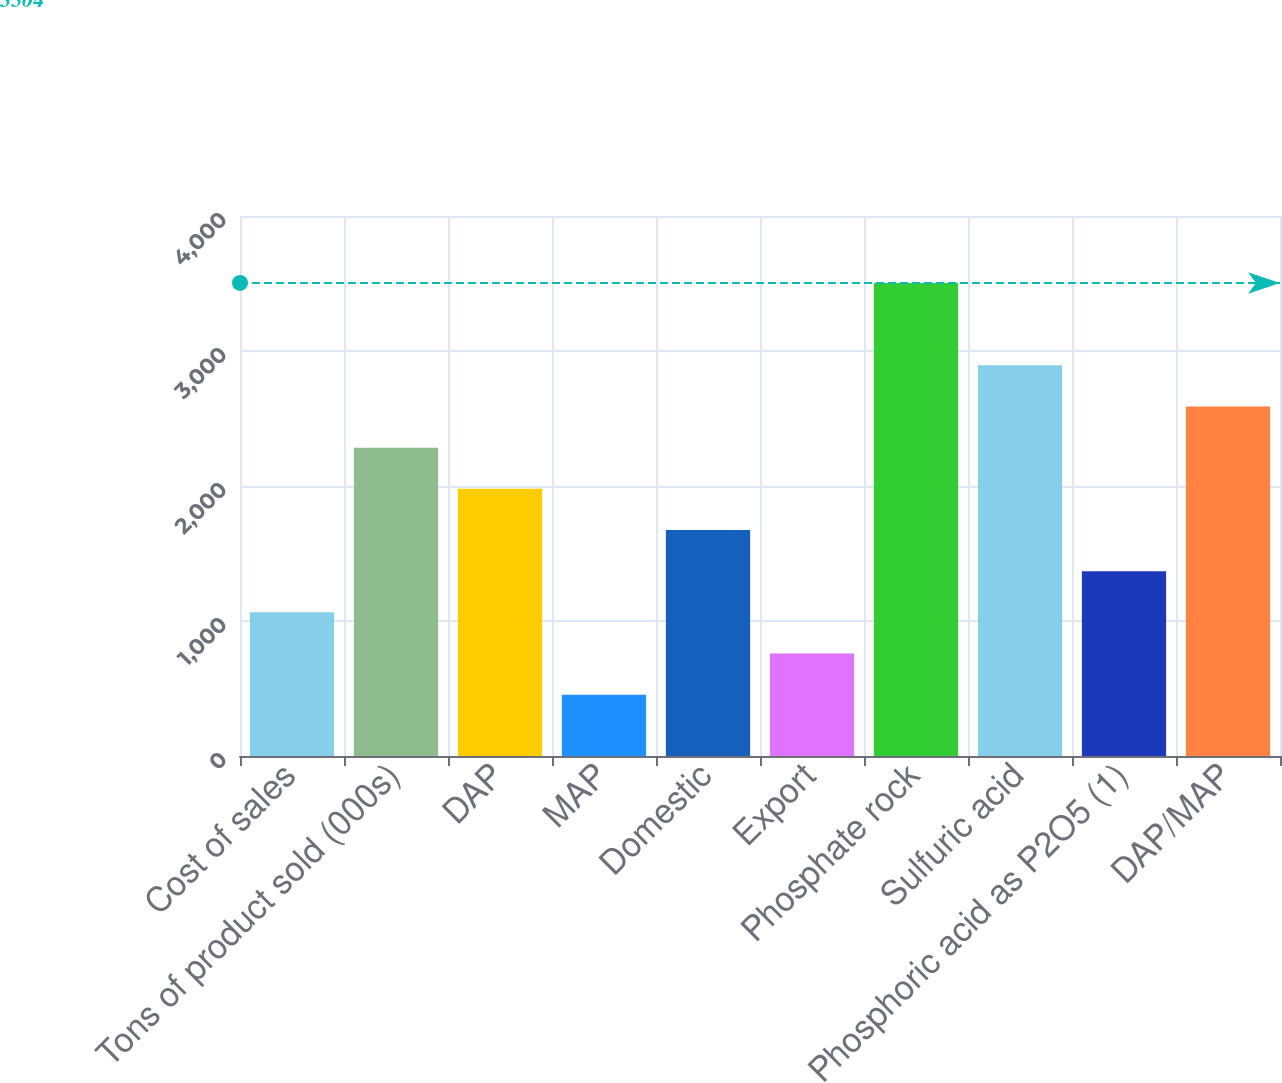<chart> <loc_0><loc_0><loc_500><loc_500><bar_chart><fcel>Cost of sales<fcel>Tons of product sold (000s)<fcel>DAP<fcel>MAP<fcel>Domestic<fcel>Export<fcel>Phosphate rock<fcel>Sulfuric acid<fcel>Phosphoric acid as P2O5 (1)<fcel>DAP/MAP<nl><fcel>1064<fcel>2284<fcel>1979<fcel>454<fcel>1674<fcel>759<fcel>3504<fcel>2894<fcel>1369<fcel>2589<nl></chart> 